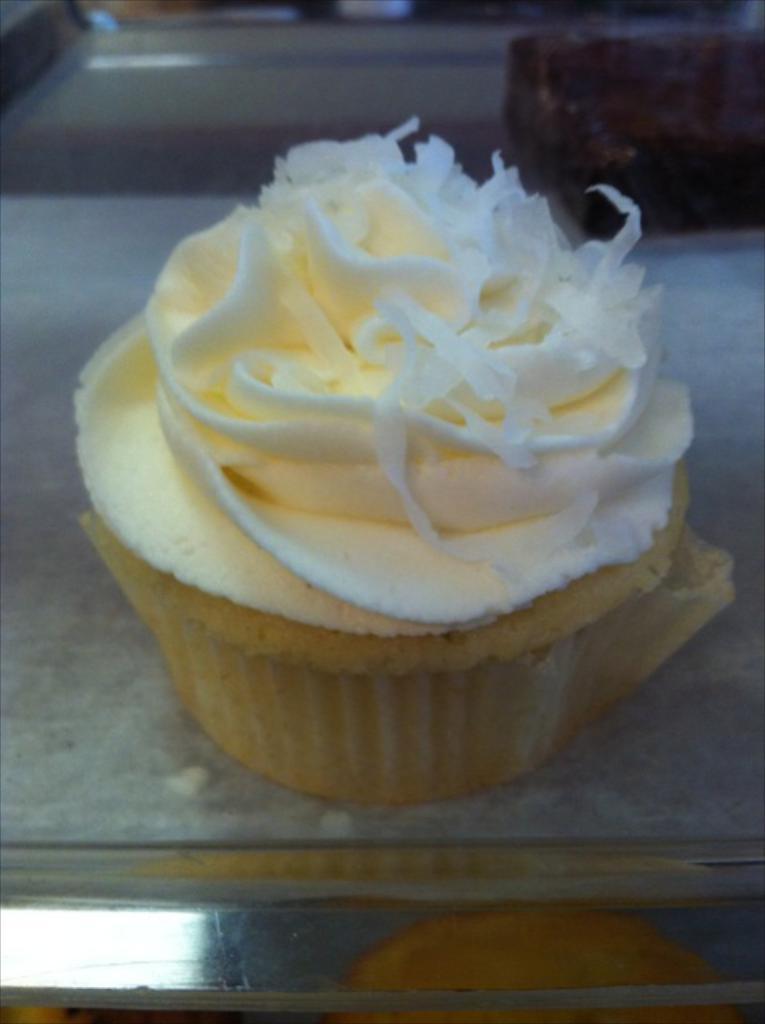Describe this image in one or two sentences. In the middle of this image, there is an ice cream in a cup. This cup is placed on a table. And the background is blurred. 